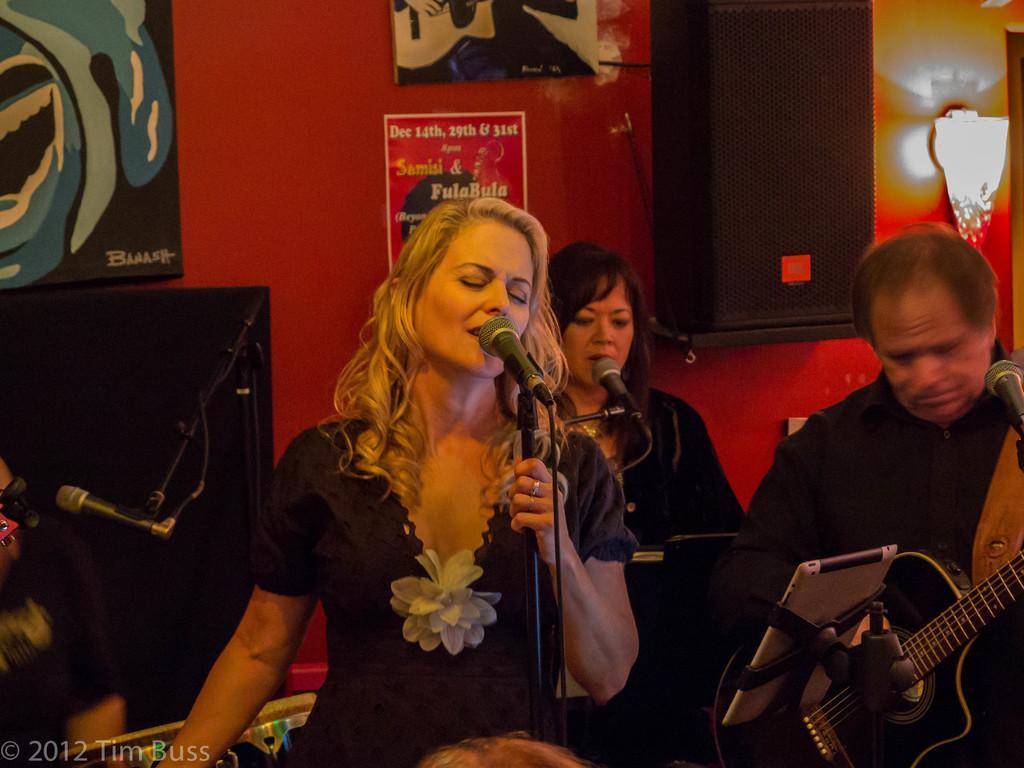How would you summarize this image in a sentence or two? The picture is a band performing. In the foreground there is a woman singing. On the right a man is playing guitar. In the background a woman is singing. There are many microphones. In the background on the wall there are many posters. On the top right there is a speaker. 